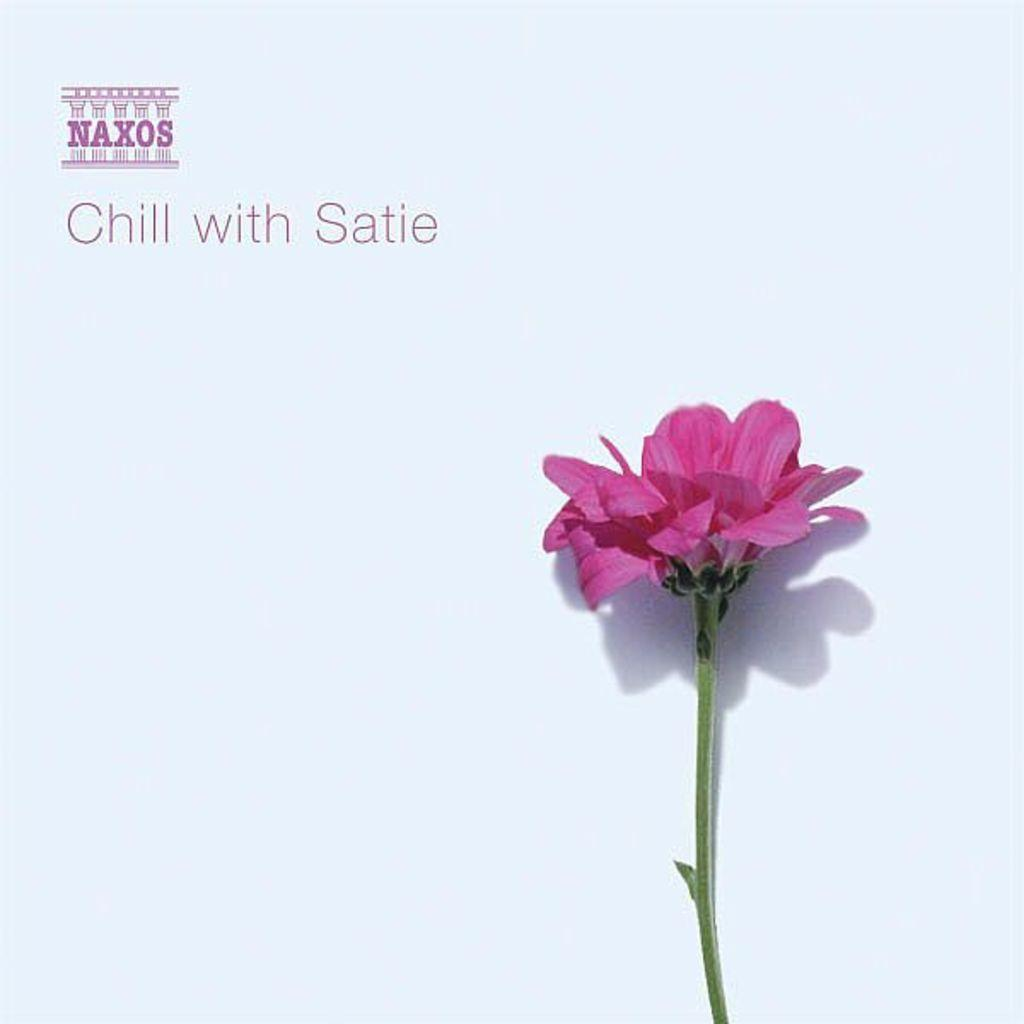What is the main subject of the image? The main subject of the image is a flower. Is there any text present in the image? Yes, there is text printed at the top of the image. What type of cabbage is being used to celebrate the birth in the image? There is no cabbage or celebration of a birth present in the image; it features a flower and text. 